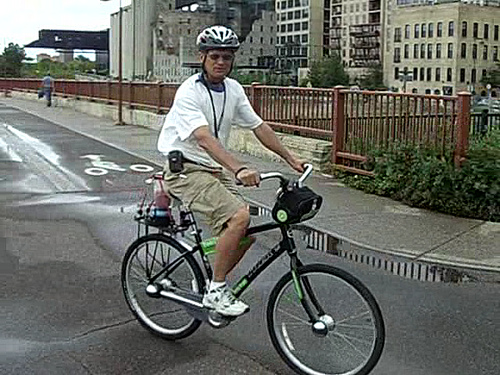Describe the weather conditions observed in the image. The sky is overcast, and the pavement appears to be slightly wet, which could imply recent rain. Despite the lack of sunshine, the visibility is clear, and the man is out enjoying his ride, suggesting the weather is mild and not extreme in temperature or conditions. 